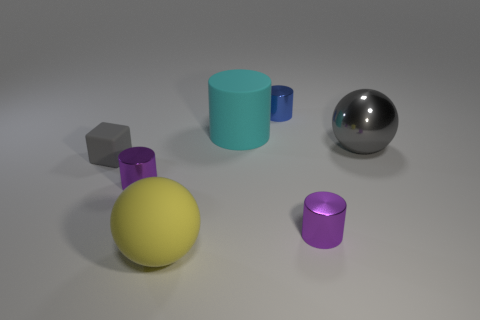Subtract all rubber cylinders. How many cylinders are left? 3 Subtract all purple cylinders. How many cylinders are left? 2 Add 1 cyan matte cylinders. How many objects exist? 8 Subtract 3 cylinders. How many cylinders are left? 1 Subtract all gray cylinders. How many yellow spheres are left? 1 Subtract all balls. How many objects are left? 5 Add 5 yellow objects. How many yellow objects exist? 6 Subtract 0 red cubes. How many objects are left? 7 Subtract all brown cylinders. Subtract all green spheres. How many cylinders are left? 4 Subtract all tiny things. Subtract all gray balls. How many objects are left? 2 